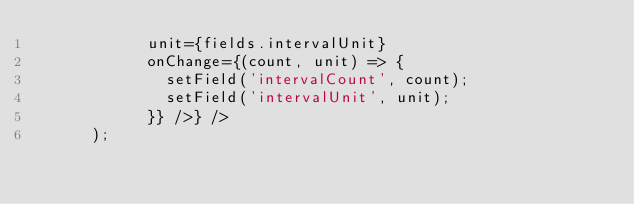<code> <loc_0><loc_0><loc_500><loc_500><_JavaScript_>            unit={fields.intervalUnit}
            onChange={(count, unit) => {
              setField('intervalCount', count);
              setField('intervalUnit', unit);
            }} />} />
      );</code> 